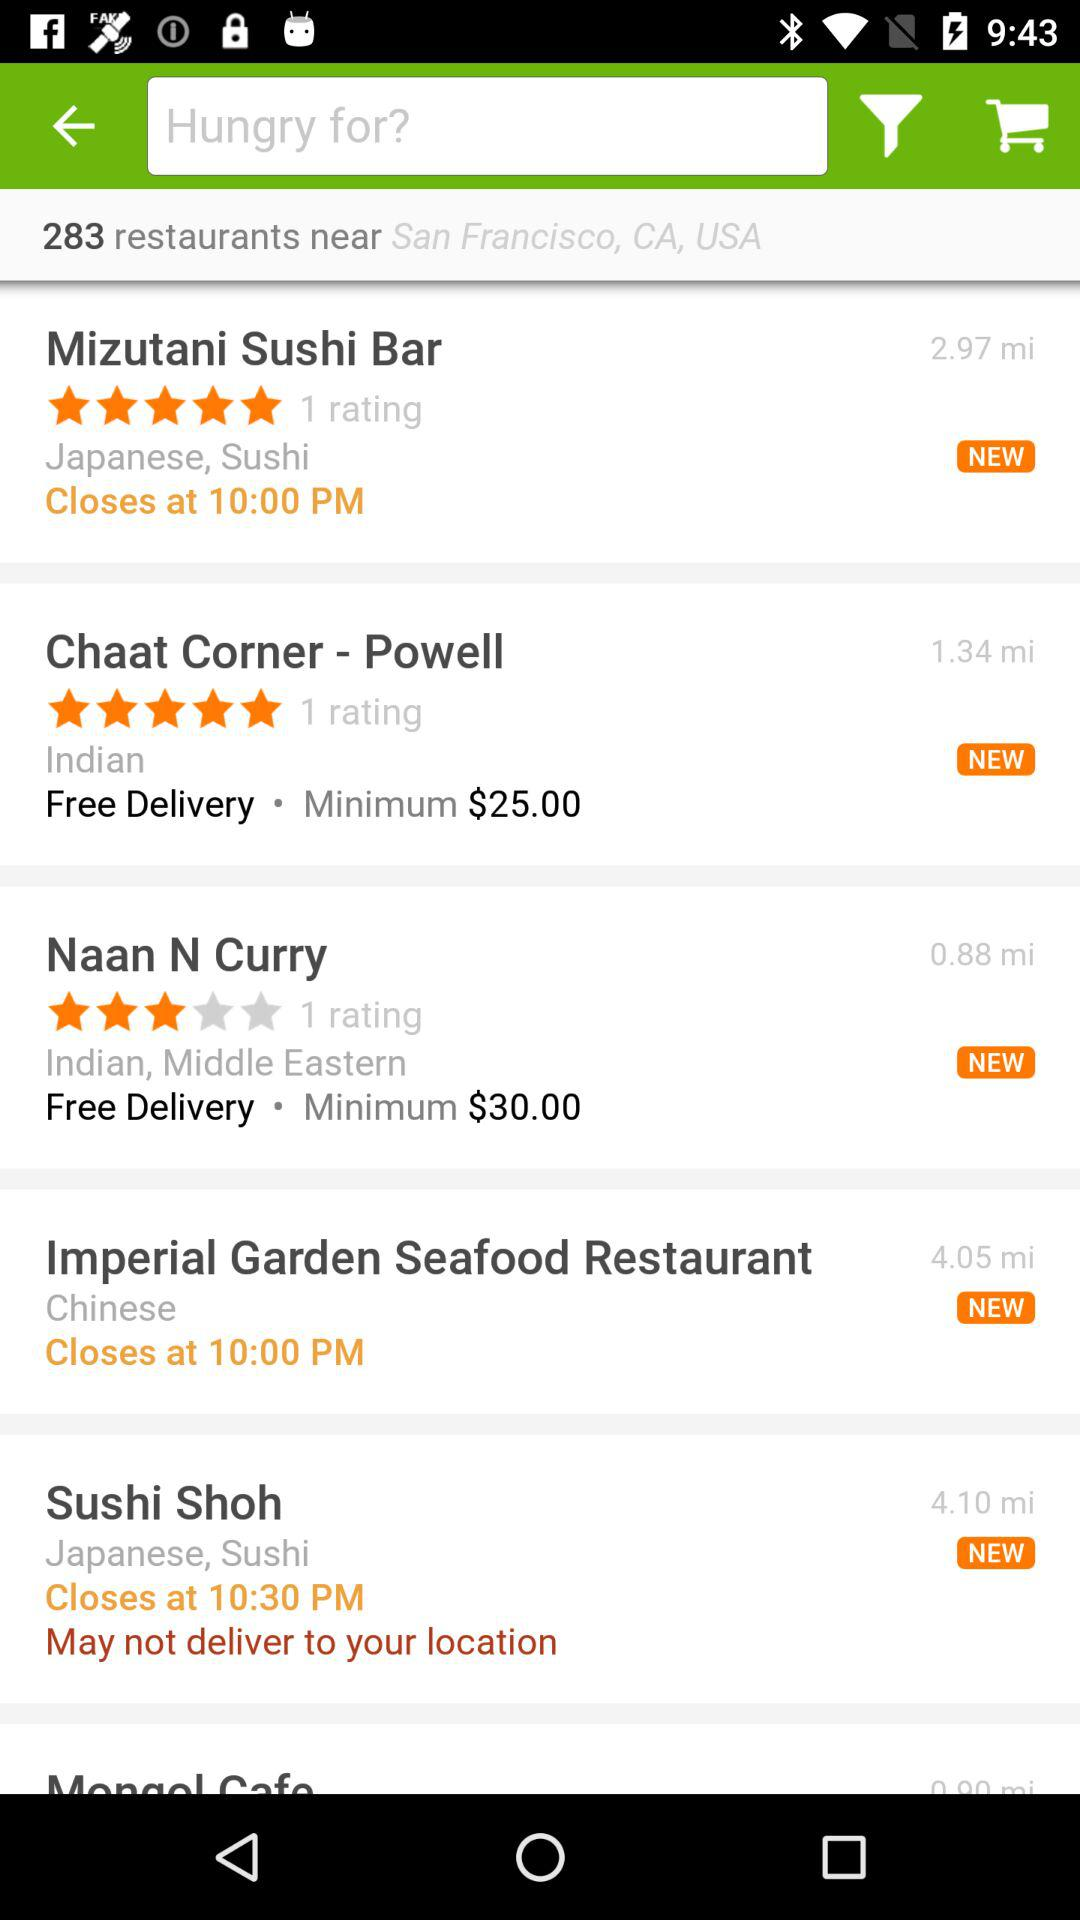What is the rating of "Chaat Corner - Powell"? The rating of "Chaat Corner - Powell" is 5 stars. 